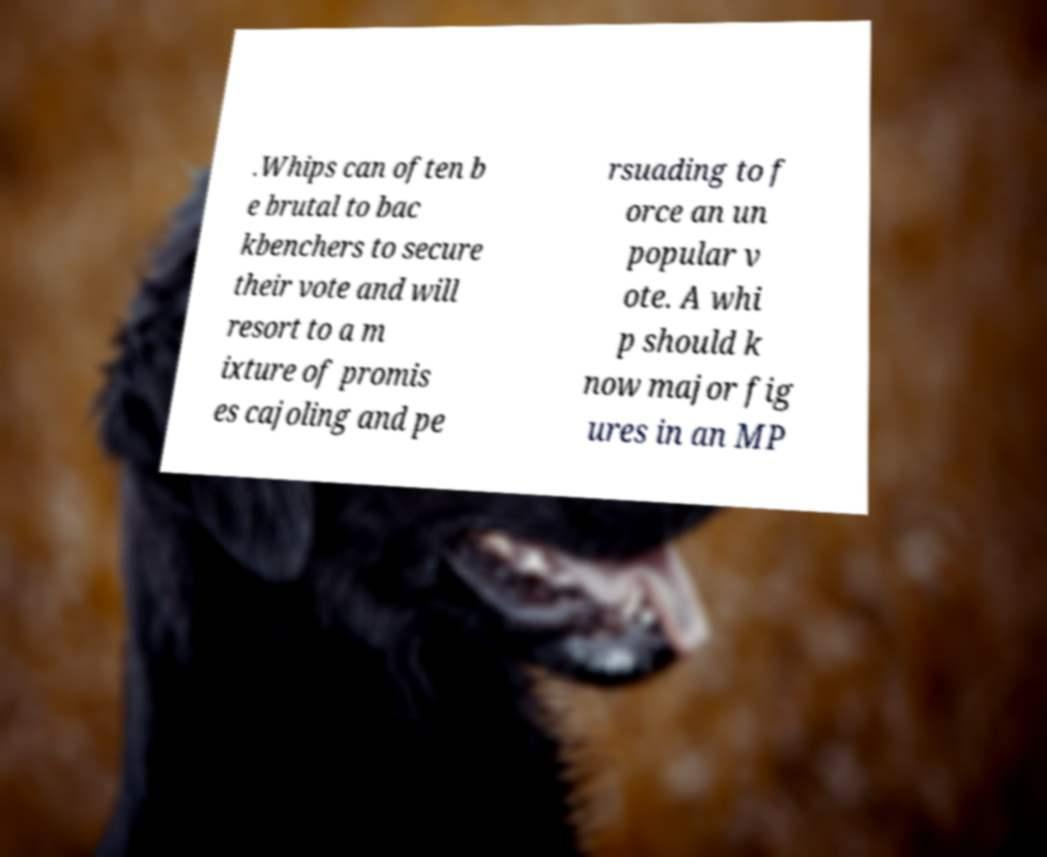I need the written content from this picture converted into text. Can you do that? .Whips can often b e brutal to bac kbenchers to secure their vote and will resort to a m ixture of promis es cajoling and pe rsuading to f orce an un popular v ote. A whi p should k now major fig ures in an MP 